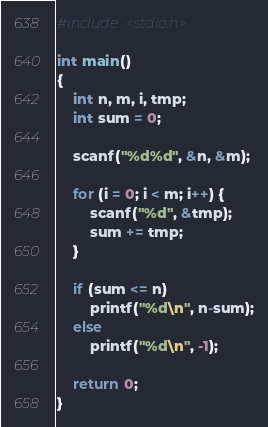<code> <loc_0><loc_0><loc_500><loc_500><_C_>#include <stdio.h>

int main()
{
    int n, m, i, tmp;
    int sum = 0;

    scanf("%d%d", &n, &m);
    
    for (i = 0; i < m; i++) {
        scanf("%d", &tmp);
        sum += tmp;
    }

    if (sum <= n)
        printf("%d\n", n-sum);
    else
        printf("%d\n", -1);

    return 0;
}</code> 